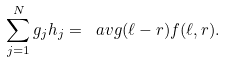<formula> <loc_0><loc_0><loc_500><loc_500>\sum _ { j = 1 } ^ { N } g _ { j } h _ { j } = \ a v g { ( \ell - r ) f ( \ell , r ) } .</formula> 